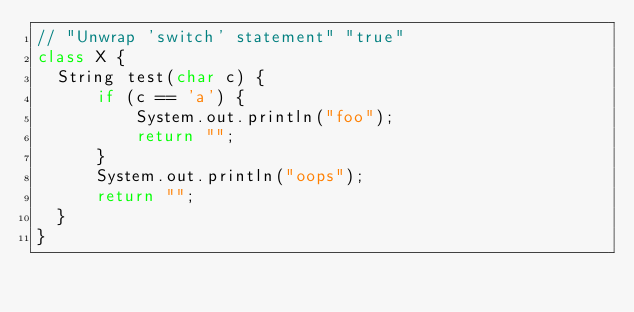<code> <loc_0><loc_0><loc_500><loc_500><_Java_>// "Unwrap 'switch' statement" "true"
class X {
  String test(char c) {
      if (c == 'a') {
          System.out.println("foo");
          return "";
      }
      System.out.println("oops");
      return "";
  }
}</code> 